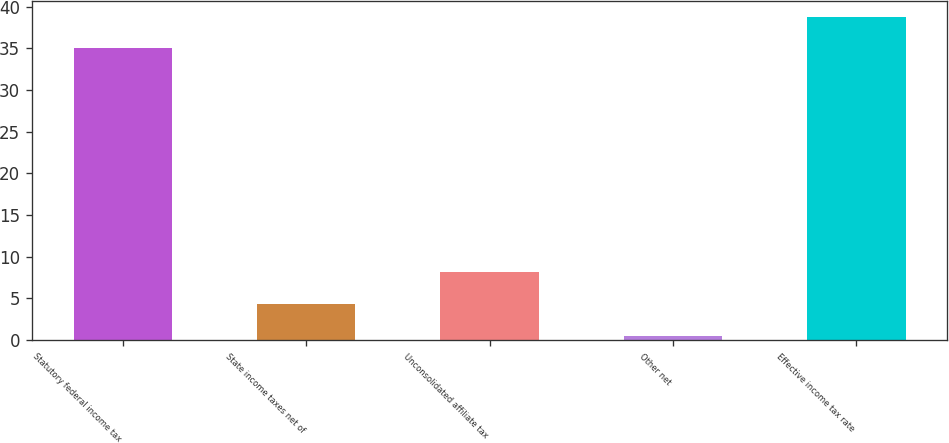<chart> <loc_0><loc_0><loc_500><loc_500><bar_chart><fcel>Statutory federal income tax<fcel>State income taxes net of<fcel>Unconsolidated affiliate tax<fcel>Other net<fcel>Effective income tax rate<nl><fcel>35<fcel>4.31<fcel>8.12<fcel>0.5<fcel>38.81<nl></chart> 